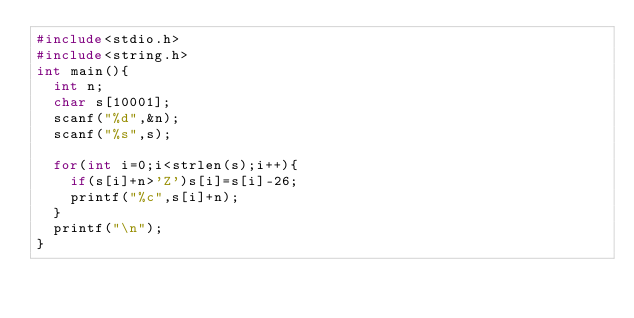<code> <loc_0><loc_0><loc_500><loc_500><_C_>#include<stdio.h>
#include<string.h>
int main(){
  int n;
  char s[10001];
  scanf("%d",&n);
  scanf("%s",s);
  
  for(int i=0;i<strlen(s);i++){
    if(s[i]+n>'Z')s[i]=s[i]-26;
    printf("%c",s[i]+n);
  }
  printf("\n");
}</code> 